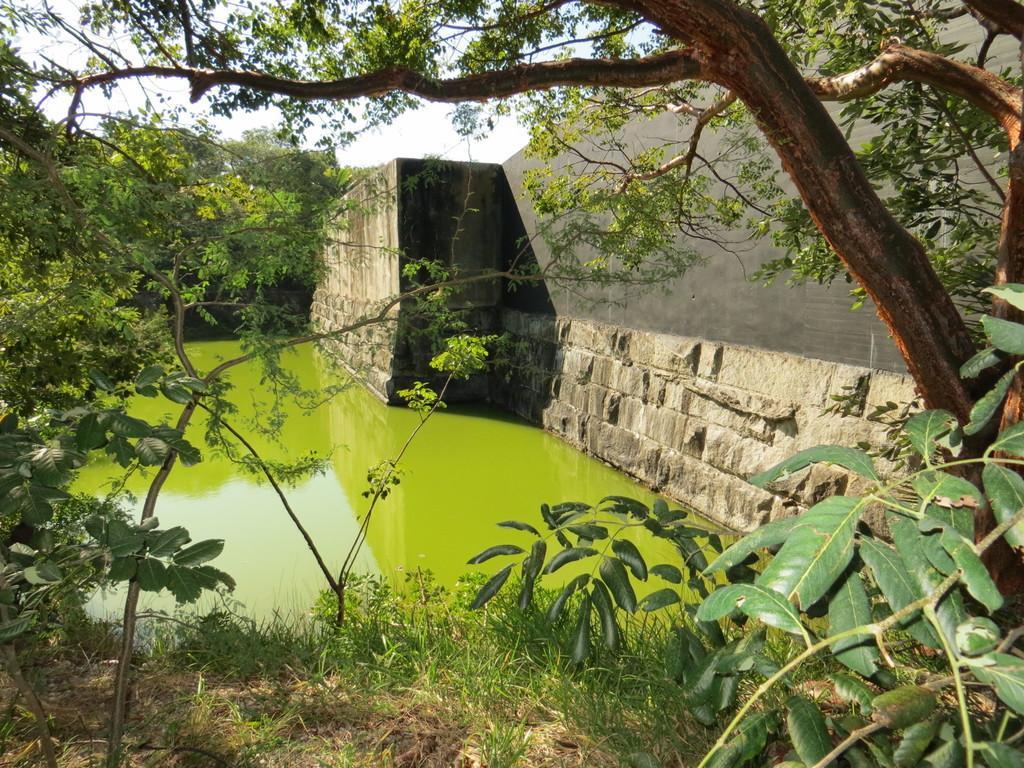Could you give a brief overview of what you see in this image? In the center of the image there is water. At the bottom of the image there is grass on the surface. On the right side of the image there is a wall. In the background of the image there are trees and sky. 